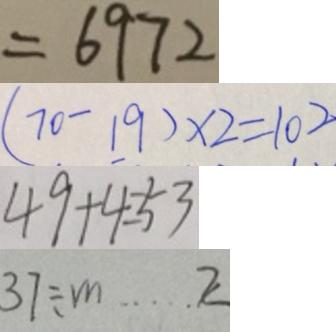<formula> <loc_0><loc_0><loc_500><loc_500>= 6 9 7 2 
 ( 7 0 - 1 9 ) \times 2 = 1 0 2 
 4 9 + 4 = 5 3 
 3 7 \div m \cdots 2</formula> 